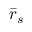<formula> <loc_0><loc_0><loc_500><loc_500>{ \bar { r } } _ { s }</formula> 